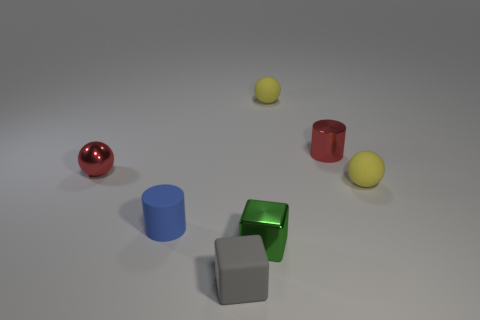Add 2 big brown shiny cylinders. How many objects exist? 9 Subtract all cylinders. How many objects are left? 5 Subtract all large green shiny things. Subtract all red balls. How many objects are left? 6 Add 2 tiny gray things. How many tiny gray things are left? 3 Add 4 large brown cubes. How many large brown cubes exist? 4 Subtract 0 cyan cylinders. How many objects are left? 7 